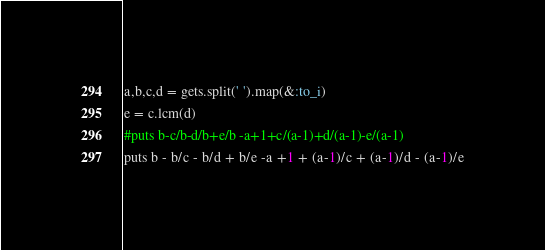<code> <loc_0><loc_0><loc_500><loc_500><_Ruby_>a,b,c,d = gets.split(' ').map(&:to_i)
e = c.lcm(d)
#puts b-c/b-d/b+e/b -a+1+c/(a-1)+d/(a-1)-e/(a-1)
puts b - b/c - b/d + b/e -a +1 + (a-1)/c + (a-1)/d - (a-1)/e
</code> 